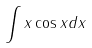<formula> <loc_0><loc_0><loc_500><loc_500>\int x \cos x d x</formula> 